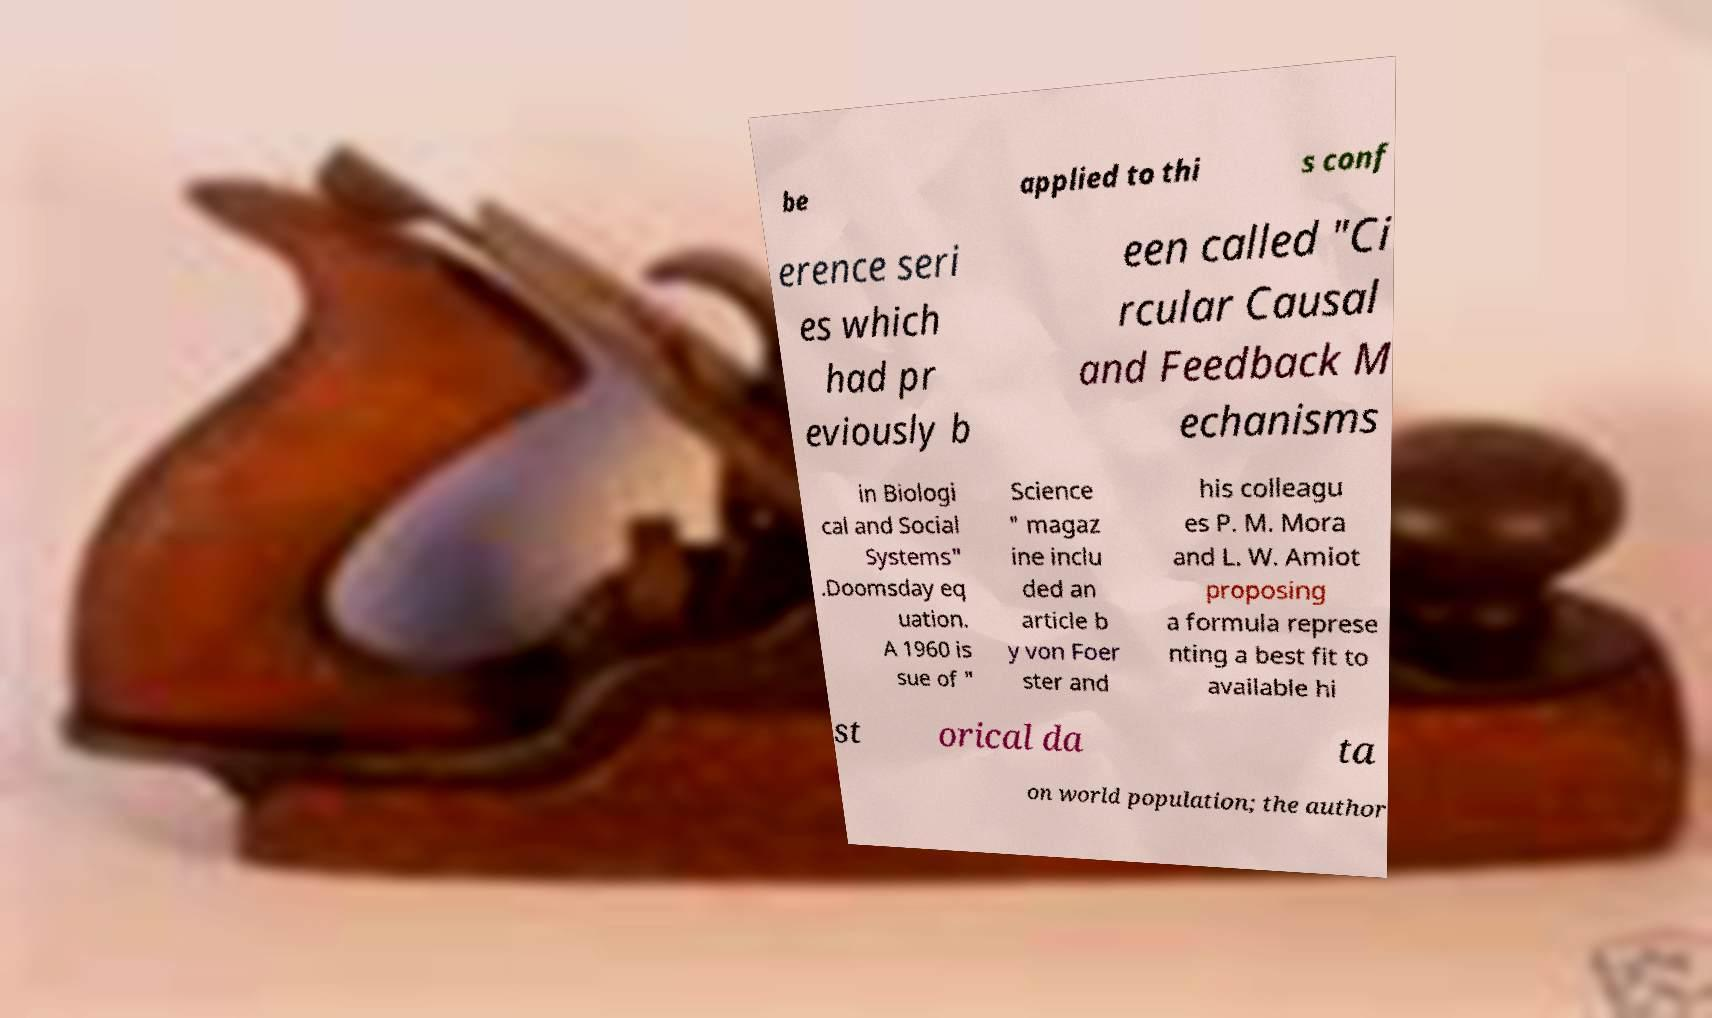Please read and relay the text visible in this image. What does it say? be applied to thi s conf erence seri es which had pr eviously b een called "Ci rcular Causal and Feedback M echanisms in Biologi cal and Social Systems" .Doomsday eq uation. A 1960 is sue of " Science " magaz ine inclu ded an article b y von Foer ster and his colleagu es P. M. Mora and L. W. Amiot proposing a formula represe nting a best fit to available hi st orical da ta on world population; the author 